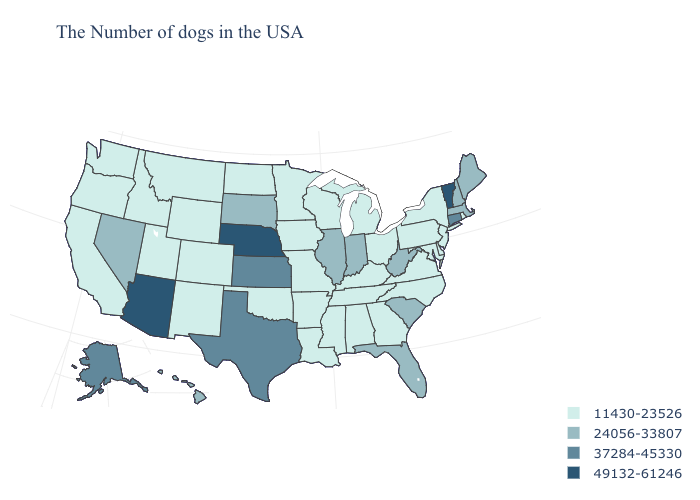Among the states that border Illinois , does Wisconsin have the lowest value?
Give a very brief answer. Yes. Does Pennsylvania have the highest value in the Northeast?
Write a very short answer. No. Name the states that have a value in the range 24056-33807?
Short answer required. Maine, Massachusetts, New Hampshire, South Carolina, West Virginia, Florida, Indiana, Illinois, South Dakota, Nevada, Hawaii. Name the states that have a value in the range 49132-61246?
Answer briefly. Vermont, Nebraska, Arizona. Name the states that have a value in the range 37284-45330?
Concise answer only. Connecticut, Kansas, Texas, Alaska. Among the states that border South Dakota , does Minnesota have the highest value?
Answer briefly. No. What is the highest value in states that border Nebraska?
Write a very short answer. 37284-45330. Among the states that border Missouri , which have the lowest value?
Concise answer only. Kentucky, Tennessee, Arkansas, Iowa, Oklahoma. Among the states that border New Hampshire , which have the lowest value?
Write a very short answer. Maine, Massachusetts. Does Oregon have the lowest value in the USA?
Quick response, please. Yes. Name the states that have a value in the range 37284-45330?
Give a very brief answer. Connecticut, Kansas, Texas, Alaska. Does Arizona have the highest value in the USA?
Keep it brief. Yes. What is the value of North Carolina?
Keep it brief. 11430-23526. What is the value of Arizona?
Be succinct. 49132-61246. Among the states that border Wisconsin , does Iowa have the lowest value?
Be succinct. Yes. 